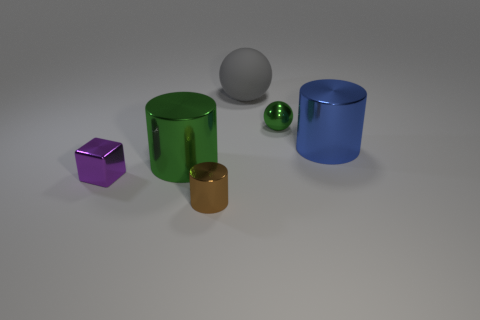There is a purple object that is the same size as the brown object; what shape is it? The purple object that corresponds in size to the brown object is a cube. Its sharp edges and equally-sized faces are characteristic of a cube's geometry. 